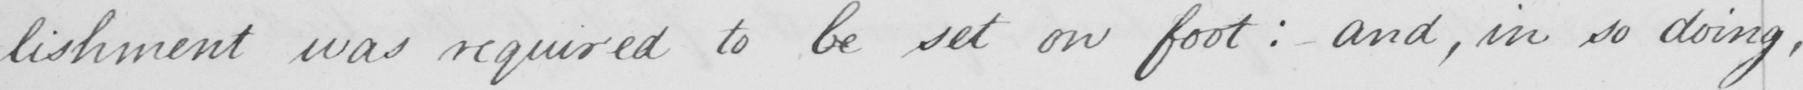Please transcribe the handwritten text in this image. -lishment was required to be set on foot :  and , in so doing , 